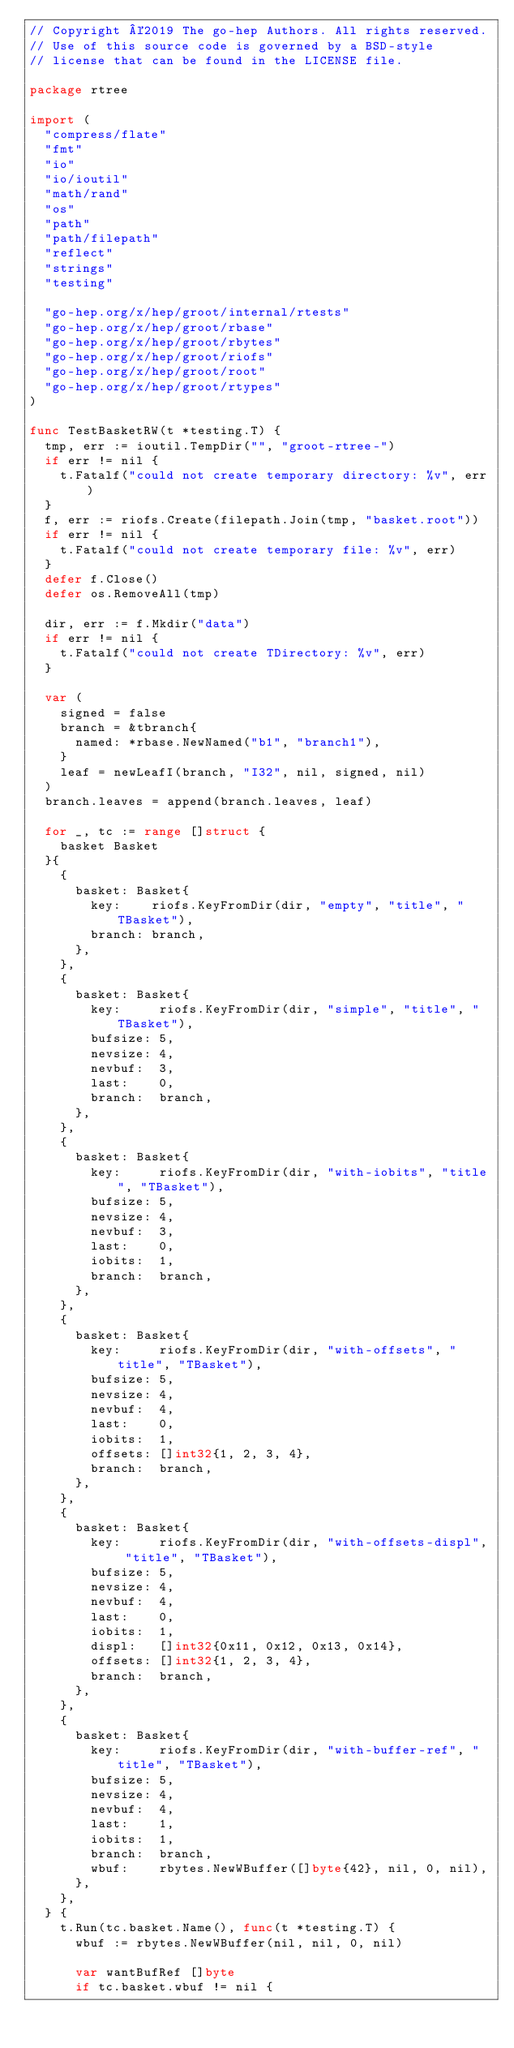<code> <loc_0><loc_0><loc_500><loc_500><_Go_>// Copyright ©2019 The go-hep Authors. All rights reserved.
// Use of this source code is governed by a BSD-style
// license that can be found in the LICENSE file.

package rtree

import (
	"compress/flate"
	"fmt"
	"io"
	"io/ioutil"
	"math/rand"
	"os"
	"path"
	"path/filepath"
	"reflect"
	"strings"
	"testing"

	"go-hep.org/x/hep/groot/internal/rtests"
	"go-hep.org/x/hep/groot/rbase"
	"go-hep.org/x/hep/groot/rbytes"
	"go-hep.org/x/hep/groot/riofs"
	"go-hep.org/x/hep/groot/root"
	"go-hep.org/x/hep/groot/rtypes"
)

func TestBasketRW(t *testing.T) {
	tmp, err := ioutil.TempDir("", "groot-rtree-")
	if err != nil {
		t.Fatalf("could not create temporary directory: %v", err)
	}
	f, err := riofs.Create(filepath.Join(tmp, "basket.root"))
	if err != nil {
		t.Fatalf("could not create temporary file: %v", err)
	}
	defer f.Close()
	defer os.RemoveAll(tmp)

	dir, err := f.Mkdir("data")
	if err != nil {
		t.Fatalf("could not create TDirectory: %v", err)
	}

	var (
		signed = false
		branch = &tbranch{
			named: *rbase.NewNamed("b1", "branch1"),
		}
		leaf = newLeafI(branch, "I32", nil, signed, nil)
	)
	branch.leaves = append(branch.leaves, leaf)

	for _, tc := range []struct {
		basket Basket
	}{
		{
			basket: Basket{
				key:    riofs.KeyFromDir(dir, "empty", "title", "TBasket"),
				branch: branch,
			},
		},
		{
			basket: Basket{
				key:     riofs.KeyFromDir(dir, "simple", "title", "TBasket"),
				bufsize: 5,
				nevsize: 4,
				nevbuf:  3,
				last:    0,
				branch:  branch,
			},
		},
		{
			basket: Basket{
				key:     riofs.KeyFromDir(dir, "with-iobits", "title", "TBasket"),
				bufsize: 5,
				nevsize: 4,
				nevbuf:  3,
				last:    0,
				iobits:  1,
				branch:  branch,
			},
		},
		{
			basket: Basket{
				key:     riofs.KeyFromDir(dir, "with-offsets", "title", "TBasket"),
				bufsize: 5,
				nevsize: 4,
				nevbuf:  4,
				last:    0,
				iobits:  1,
				offsets: []int32{1, 2, 3, 4},
				branch:  branch,
			},
		},
		{
			basket: Basket{
				key:     riofs.KeyFromDir(dir, "with-offsets-displ", "title", "TBasket"),
				bufsize: 5,
				nevsize: 4,
				nevbuf:  4,
				last:    0,
				iobits:  1,
				displ:   []int32{0x11, 0x12, 0x13, 0x14},
				offsets: []int32{1, 2, 3, 4},
				branch:  branch,
			},
		},
		{
			basket: Basket{
				key:     riofs.KeyFromDir(dir, "with-buffer-ref", "title", "TBasket"),
				bufsize: 5,
				nevsize: 4,
				nevbuf:  4,
				last:    1,
				iobits:  1,
				branch:  branch,
				wbuf:    rbytes.NewWBuffer([]byte{42}, nil, 0, nil),
			},
		},
	} {
		t.Run(tc.basket.Name(), func(t *testing.T) {
			wbuf := rbytes.NewWBuffer(nil, nil, 0, nil)

			var wantBufRef []byte
			if tc.basket.wbuf != nil {</code> 